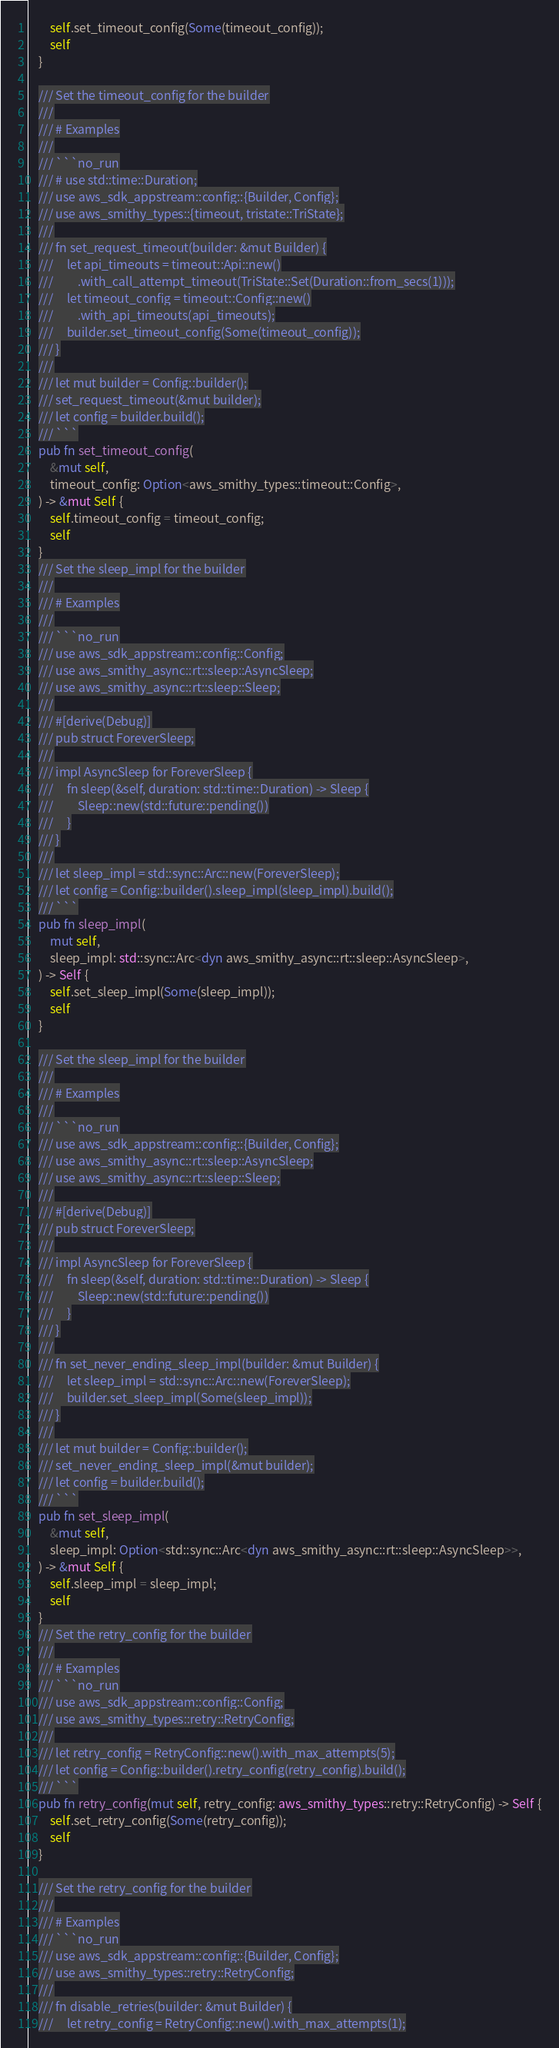<code> <loc_0><loc_0><loc_500><loc_500><_Rust_>        self.set_timeout_config(Some(timeout_config));
        self
    }

    /// Set the timeout_config for the builder
    ///
    /// # Examples
    ///
    /// ```no_run
    /// # use std::time::Duration;
    /// use aws_sdk_appstream::config::{Builder, Config};
    /// use aws_smithy_types::{timeout, tristate::TriState};
    ///
    /// fn set_request_timeout(builder: &mut Builder) {
    ///     let api_timeouts = timeout::Api::new()
    ///         .with_call_attempt_timeout(TriState::Set(Duration::from_secs(1)));
    ///     let timeout_config = timeout::Config::new()
    ///         .with_api_timeouts(api_timeouts);
    ///     builder.set_timeout_config(Some(timeout_config));
    /// }
    ///
    /// let mut builder = Config::builder();
    /// set_request_timeout(&mut builder);
    /// let config = builder.build();
    /// ```
    pub fn set_timeout_config(
        &mut self,
        timeout_config: Option<aws_smithy_types::timeout::Config>,
    ) -> &mut Self {
        self.timeout_config = timeout_config;
        self
    }
    /// Set the sleep_impl for the builder
    ///
    /// # Examples
    ///
    /// ```no_run
    /// use aws_sdk_appstream::config::Config;
    /// use aws_smithy_async::rt::sleep::AsyncSleep;
    /// use aws_smithy_async::rt::sleep::Sleep;
    ///
    /// #[derive(Debug)]
    /// pub struct ForeverSleep;
    ///
    /// impl AsyncSleep for ForeverSleep {
    ///     fn sleep(&self, duration: std::time::Duration) -> Sleep {
    ///         Sleep::new(std::future::pending())
    ///     }
    /// }
    ///
    /// let sleep_impl = std::sync::Arc::new(ForeverSleep);
    /// let config = Config::builder().sleep_impl(sleep_impl).build();
    /// ```
    pub fn sleep_impl(
        mut self,
        sleep_impl: std::sync::Arc<dyn aws_smithy_async::rt::sleep::AsyncSleep>,
    ) -> Self {
        self.set_sleep_impl(Some(sleep_impl));
        self
    }

    /// Set the sleep_impl for the builder
    ///
    /// # Examples
    ///
    /// ```no_run
    /// use aws_sdk_appstream::config::{Builder, Config};
    /// use aws_smithy_async::rt::sleep::AsyncSleep;
    /// use aws_smithy_async::rt::sleep::Sleep;
    ///
    /// #[derive(Debug)]
    /// pub struct ForeverSleep;
    ///
    /// impl AsyncSleep for ForeverSleep {
    ///     fn sleep(&self, duration: std::time::Duration) -> Sleep {
    ///         Sleep::new(std::future::pending())
    ///     }
    /// }
    ///
    /// fn set_never_ending_sleep_impl(builder: &mut Builder) {
    ///     let sleep_impl = std::sync::Arc::new(ForeverSleep);
    ///     builder.set_sleep_impl(Some(sleep_impl));
    /// }
    ///
    /// let mut builder = Config::builder();
    /// set_never_ending_sleep_impl(&mut builder);
    /// let config = builder.build();
    /// ```
    pub fn set_sleep_impl(
        &mut self,
        sleep_impl: Option<std::sync::Arc<dyn aws_smithy_async::rt::sleep::AsyncSleep>>,
    ) -> &mut Self {
        self.sleep_impl = sleep_impl;
        self
    }
    /// Set the retry_config for the builder
    ///
    /// # Examples
    /// ```no_run
    /// use aws_sdk_appstream::config::Config;
    /// use aws_smithy_types::retry::RetryConfig;
    ///
    /// let retry_config = RetryConfig::new().with_max_attempts(5);
    /// let config = Config::builder().retry_config(retry_config).build();
    /// ```
    pub fn retry_config(mut self, retry_config: aws_smithy_types::retry::RetryConfig) -> Self {
        self.set_retry_config(Some(retry_config));
        self
    }

    /// Set the retry_config for the builder
    ///
    /// # Examples
    /// ```no_run
    /// use aws_sdk_appstream::config::{Builder, Config};
    /// use aws_smithy_types::retry::RetryConfig;
    ///
    /// fn disable_retries(builder: &mut Builder) {
    ///     let retry_config = RetryConfig::new().with_max_attempts(1);</code> 